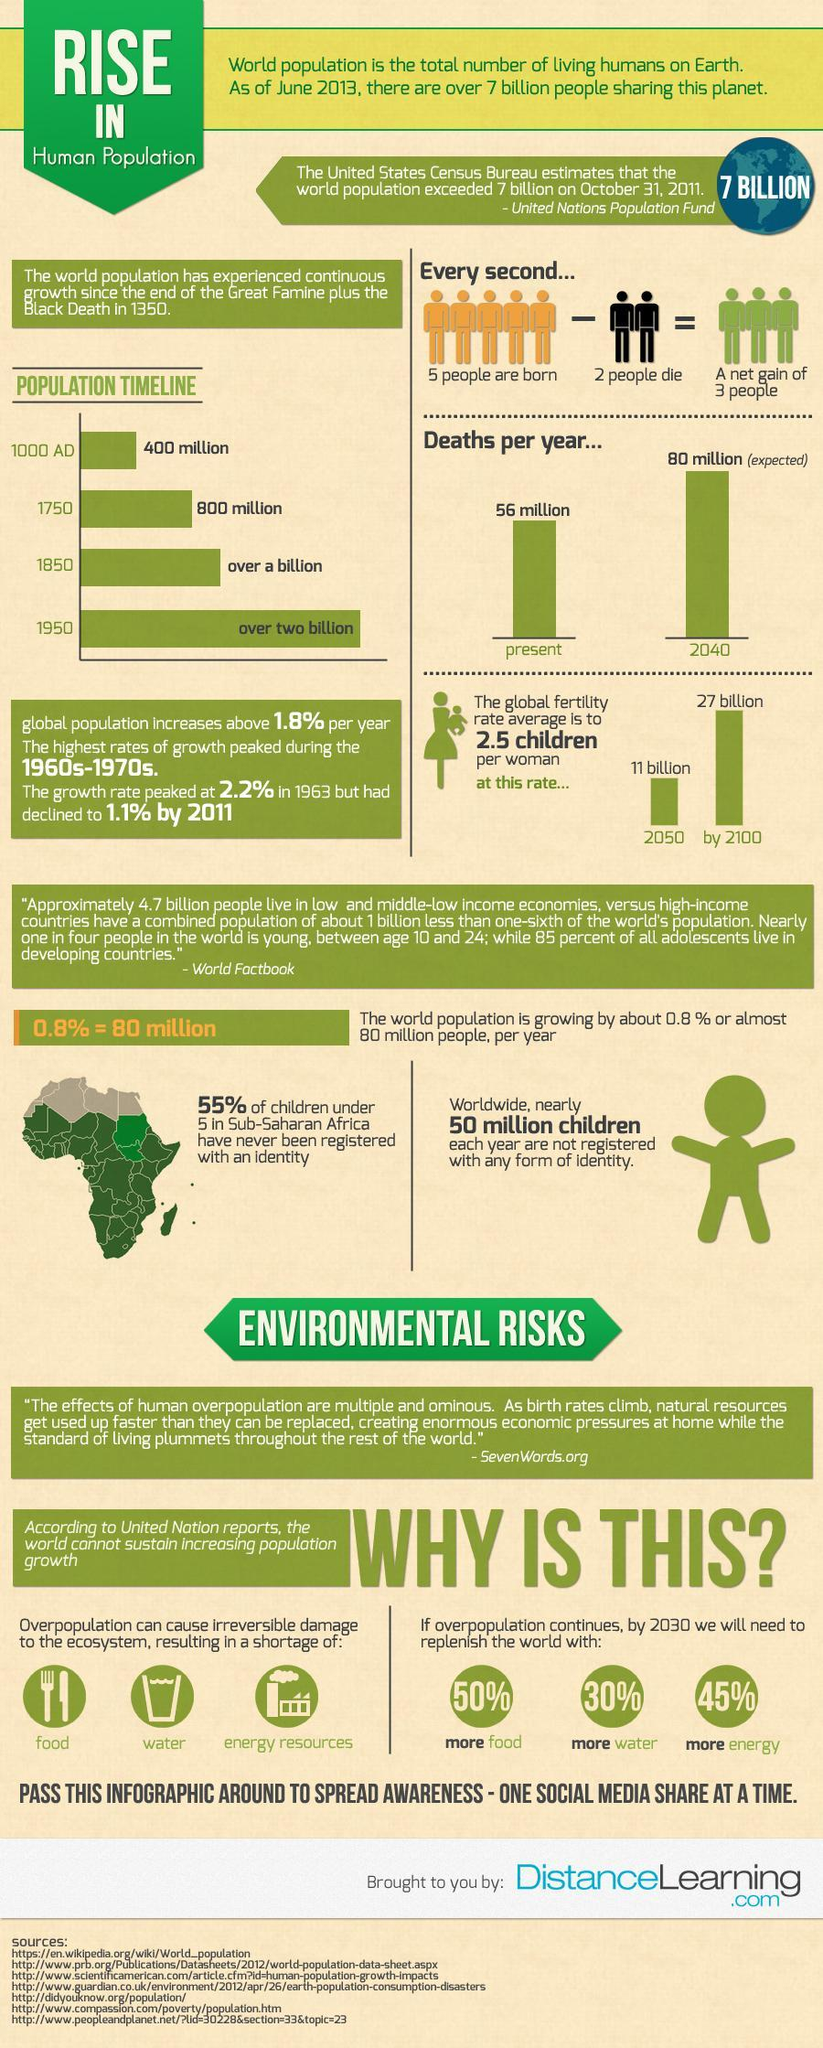How many people will be there on earth by 2100?
Answer the question with a short phrase. 27 billion How much water would require humans to survive by 2030? 30% Which element of the ecosystem gets affected "second" due to overpopulation? water What are the major factors that get affected by Overpopulation? food, water, energy resources How many human beings are losing their life every second? 2 How many new life is getting started in every second? 5 In which year the second-highest population marked in the timeline? 1850 How much food would require humans to survive by 2030? 50% Which color code are the people who get dead- green, black, orange, yellow? black Which element of the ecosystem gets affected "third" due to overpopulation? Energy resources 